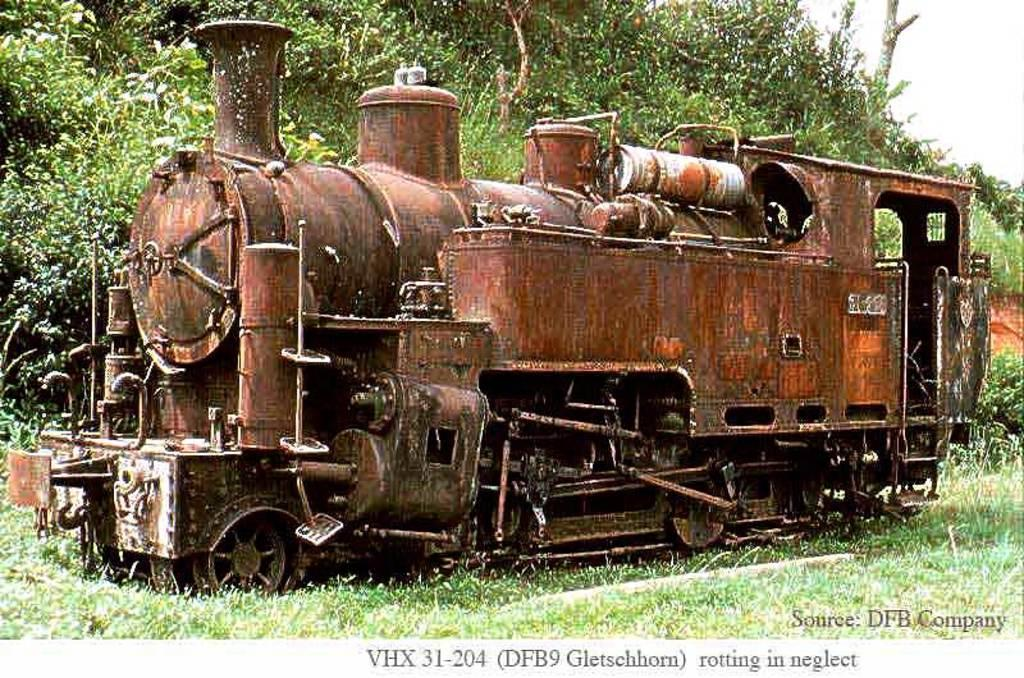What is the main subject of the image? The main subject of the image is a train. Where is the train located in the image? The train is on the grass. What can be seen in the background of the image? There are plants visible in the background of the image. What is present at the bottom of the image? There is text at the bottom of the image. What type of force is being exerted by the army on the nerves in the image? There is no army or mention of nerves in the image; it features a train on the grass with plants in the background and text at the bottom. 